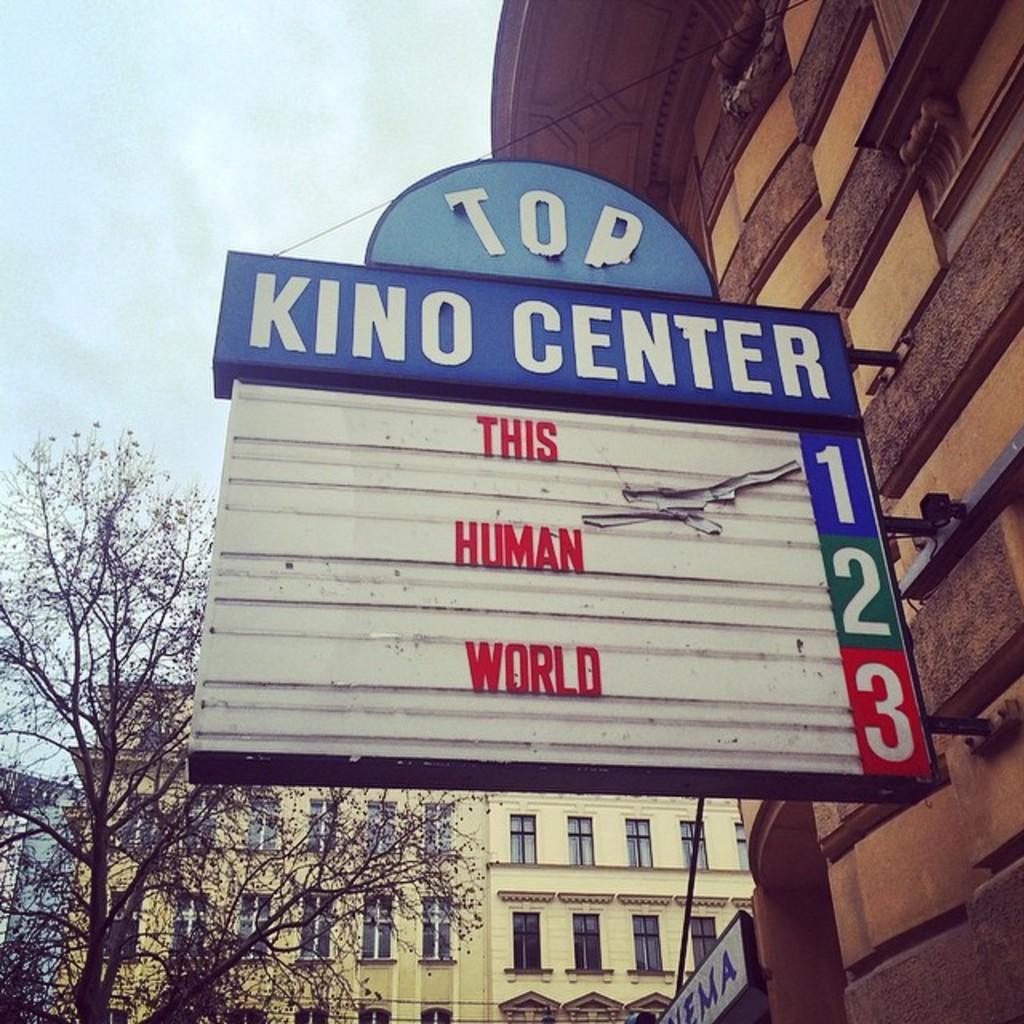Please provide a concise description of this image. This image consists of buildings. In the front, we can see a board fixed to a wall. On which we can see text. On the left, there is a tree. At the top, there is sky. 